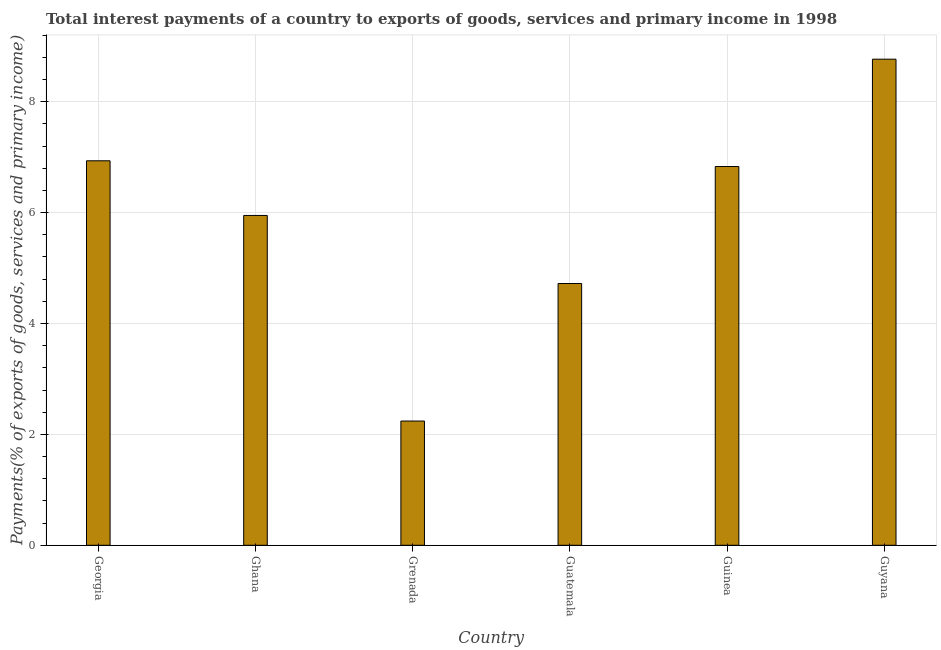Does the graph contain grids?
Give a very brief answer. Yes. What is the title of the graph?
Give a very brief answer. Total interest payments of a country to exports of goods, services and primary income in 1998. What is the label or title of the Y-axis?
Provide a succinct answer. Payments(% of exports of goods, services and primary income). What is the total interest payments on external debt in Guatemala?
Provide a succinct answer. 4.72. Across all countries, what is the maximum total interest payments on external debt?
Keep it short and to the point. 8.77. Across all countries, what is the minimum total interest payments on external debt?
Make the answer very short. 2.24. In which country was the total interest payments on external debt maximum?
Offer a terse response. Guyana. In which country was the total interest payments on external debt minimum?
Provide a succinct answer. Grenada. What is the sum of the total interest payments on external debt?
Give a very brief answer. 35.44. What is the difference between the total interest payments on external debt in Guinea and Guyana?
Offer a terse response. -1.94. What is the average total interest payments on external debt per country?
Give a very brief answer. 5.91. What is the median total interest payments on external debt?
Offer a terse response. 6.39. What is the ratio of the total interest payments on external debt in Grenada to that in Guinea?
Offer a terse response. 0.33. What is the difference between the highest and the second highest total interest payments on external debt?
Provide a succinct answer. 1.83. What is the difference between the highest and the lowest total interest payments on external debt?
Keep it short and to the point. 6.53. In how many countries, is the total interest payments on external debt greater than the average total interest payments on external debt taken over all countries?
Keep it short and to the point. 4. What is the difference between two consecutive major ticks on the Y-axis?
Your answer should be compact. 2. Are the values on the major ticks of Y-axis written in scientific E-notation?
Your answer should be compact. No. What is the Payments(% of exports of goods, services and primary income) in Georgia?
Provide a succinct answer. 6.93. What is the Payments(% of exports of goods, services and primary income) of Ghana?
Your response must be concise. 5.95. What is the Payments(% of exports of goods, services and primary income) in Grenada?
Keep it short and to the point. 2.24. What is the Payments(% of exports of goods, services and primary income) of Guatemala?
Offer a terse response. 4.72. What is the Payments(% of exports of goods, services and primary income) in Guinea?
Offer a very short reply. 6.83. What is the Payments(% of exports of goods, services and primary income) of Guyana?
Make the answer very short. 8.77. What is the difference between the Payments(% of exports of goods, services and primary income) in Georgia and Ghana?
Offer a very short reply. 0.99. What is the difference between the Payments(% of exports of goods, services and primary income) in Georgia and Grenada?
Provide a short and direct response. 4.69. What is the difference between the Payments(% of exports of goods, services and primary income) in Georgia and Guatemala?
Your response must be concise. 2.21. What is the difference between the Payments(% of exports of goods, services and primary income) in Georgia and Guinea?
Your response must be concise. 0.1. What is the difference between the Payments(% of exports of goods, services and primary income) in Georgia and Guyana?
Your answer should be compact. -1.83. What is the difference between the Payments(% of exports of goods, services and primary income) in Ghana and Grenada?
Provide a succinct answer. 3.71. What is the difference between the Payments(% of exports of goods, services and primary income) in Ghana and Guatemala?
Ensure brevity in your answer.  1.23. What is the difference between the Payments(% of exports of goods, services and primary income) in Ghana and Guinea?
Give a very brief answer. -0.88. What is the difference between the Payments(% of exports of goods, services and primary income) in Ghana and Guyana?
Provide a succinct answer. -2.82. What is the difference between the Payments(% of exports of goods, services and primary income) in Grenada and Guatemala?
Ensure brevity in your answer.  -2.48. What is the difference between the Payments(% of exports of goods, services and primary income) in Grenada and Guinea?
Provide a short and direct response. -4.59. What is the difference between the Payments(% of exports of goods, services and primary income) in Grenada and Guyana?
Offer a terse response. -6.53. What is the difference between the Payments(% of exports of goods, services and primary income) in Guatemala and Guinea?
Your response must be concise. -2.11. What is the difference between the Payments(% of exports of goods, services and primary income) in Guatemala and Guyana?
Offer a very short reply. -4.05. What is the difference between the Payments(% of exports of goods, services and primary income) in Guinea and Guyana?
Provide a short and direct response. -1.94. What is the ratio of the Payments(% of exports of goods, services and primary income) in Georgia to that in Ghana?
Your response must be concise. 1.17. What is the ratio of the Payments(% of exports of goods, services and primary income) in Georgia to that in Grenada?
Your answer should be very brief. 3.1. What is the ratio of the Payments(% of exports of goods, services and primary income) in Georgia to that in Guatemala?
Your answer should be compact. 1.47. What is the ratio of the Payments(% of exports of goods, services and primary income) in Georgia to that in Guinea?
Provide a succinct answer. 1.01. What is the ratio of the Payments(% of exports of goods, services and primary income) in Georgia to that in Guyana?
Ensure brevity in your answer.  0.79. What is the ratio of the Payments(% of exports of goods, services and primary income) in Ghana to that in Grenada?
Make the answer very short. 2.65. What is the ratio of the Payments(% of exports of goods, services and primary income) in Ghana to that in Guatemala?
Your answer should be compact. 1.26. What is the ratio of the Payments(% of exports of goods, services and primary income) in Ghana to that in Guinea?
Your answer should be very brief. 0.87. What is the ratio of the Payments(% of exports of goods, services and primary income) in Ghana to that in Guyana?
Ensure brevity in your answer.  0.68. What is the ratio of the Payments(% of exports of goods, services and primary income) in Grenada to that in Guatemala?
Ensure brevity in your answer.  0.47. What is the ratio of the Payments(% of exports of goods, services and primary income) in Grenada to that in Guinea?
Your answer should be compact. 0.33. What is the ratio of the Payments(% of exports of goods, services and primary income) in Grenada to that in Guyana?
Your response must be concise. 0.26. What is the ratio of the Payments(% of exports of goods, services and primary income) in Guatemala to that in Guinea?
Give a very brief answer. 0.69. What is the ratio of the Payments(% of exports of goods, services and primary income) in Guatemala to that in Guyana?
Ensure brevity in your answer.  0.54. What is the ratio of the Payments(% of exports of goods, services and primary income) in Guinea to that in Guyana?
Your response must be concise. 0.78. 